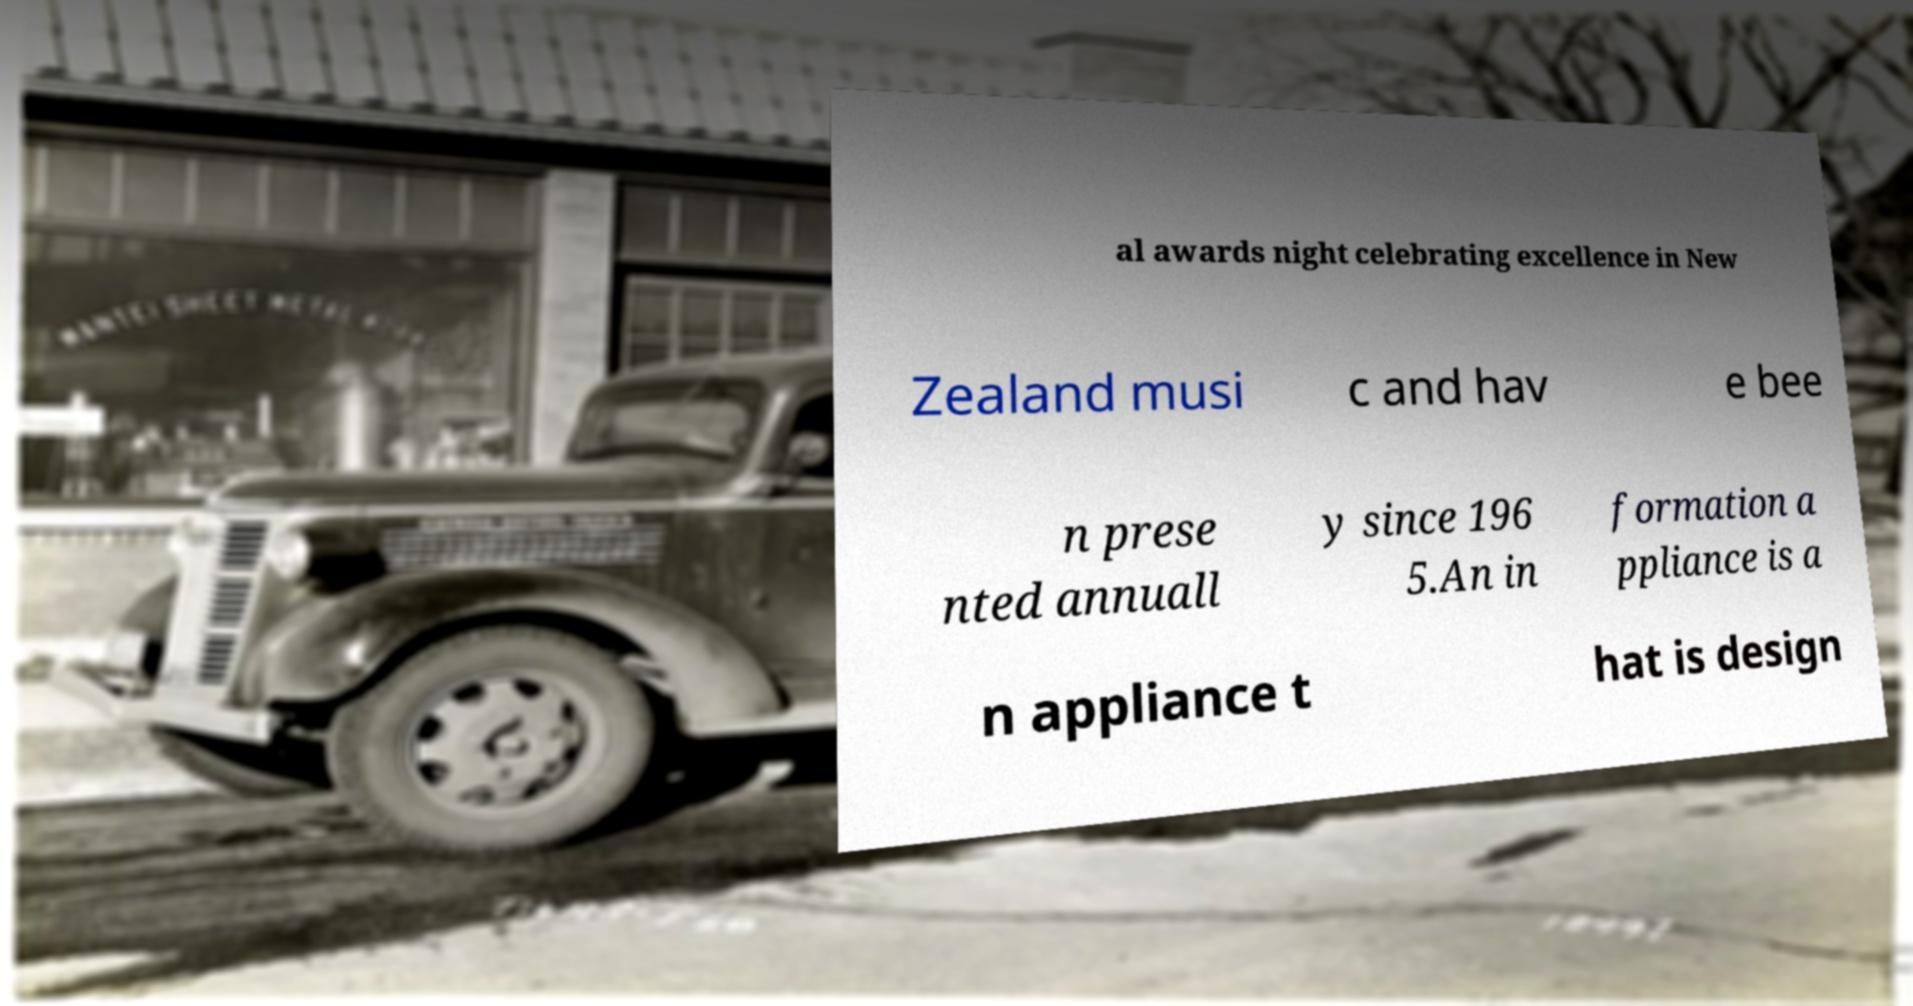Could you assist in decoding the text presented in this image and type it out clearly? al awards night celebrating excellence in New Zealand musi c and hav e bee n prese nted annuall y since 196 5.An in formation a ppliance is a n appliance t hat is design 